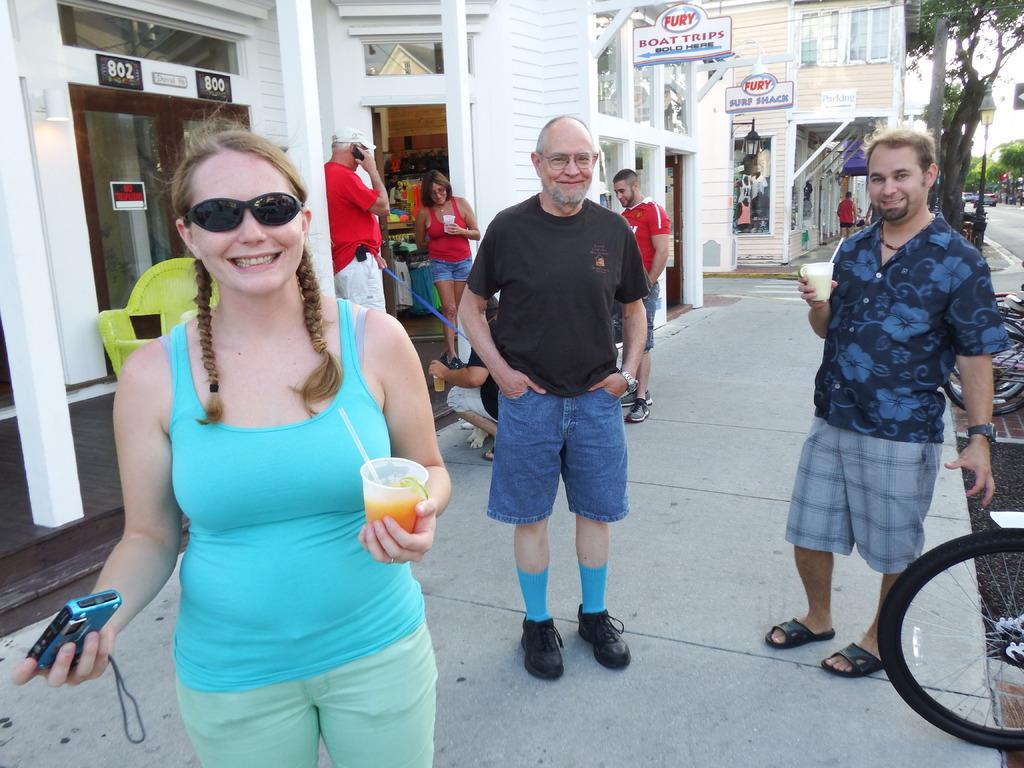Could you give a brief overview of what you see in this image? The picture is taken outside a city on a footpath. On the right there are bicycles and a person standing. In the center of the picture there is a woman and a man standing. In the center of the picture there are buildings, people, boards and other objects. In the background there are trees, road, street light, vehicles, buildings, people and various objects. 